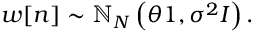<formula> <loc_0><loc_0><loc_500><loc_500>w [ n ] \sim \mathbb { N } _ { N } \left ( \theta { 1 } , \sigma ^ { 2 } { I } \right ) .</formula> 